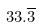Convert formula to latex. <formula><loc_0><loc_0><loc_500><loc_500>3 3 . \overline { 3 }</formula> 